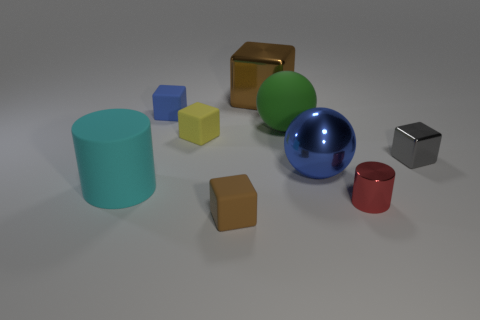How many other objects are the same shape as the tiny gray metal thing?
Your answer should be compact. 4. What is the shape of the metallic object in front of the blue thing to the right of the cube that is in front of the gray object?
Your answer should be very brief. Cylinder. How many objects are tiny gray things or objects behind the small gray shiny thing?
Provide a succinct answer. 5. Does the big thing behind the green sphere have the same shape as the small rubber object left of the yellow rubber cube?
Offer a very short reply. Yes. How many objects are either red objects or big cyan rubber things?
Offer a terse response. 2. Is there a big brown shiny cylinder?
Make the answer very short. No. Do the brown object that is behind the brown rubber cube and the large green thing have the same material?
Offer a very short reply. No. Are there any small brown things that have the same shape as the big brown thing?
Offer a very short reply. Yes. Is the number of tiny blue rubber objects that are right of the tiny gray block the same as the number of big cyan metallic spheres?
Your answer should be compact. Yes. What is the red cylinder in front of the brown thing that is behind the gray metal block made of?
Your answer should be compact. Metal. 